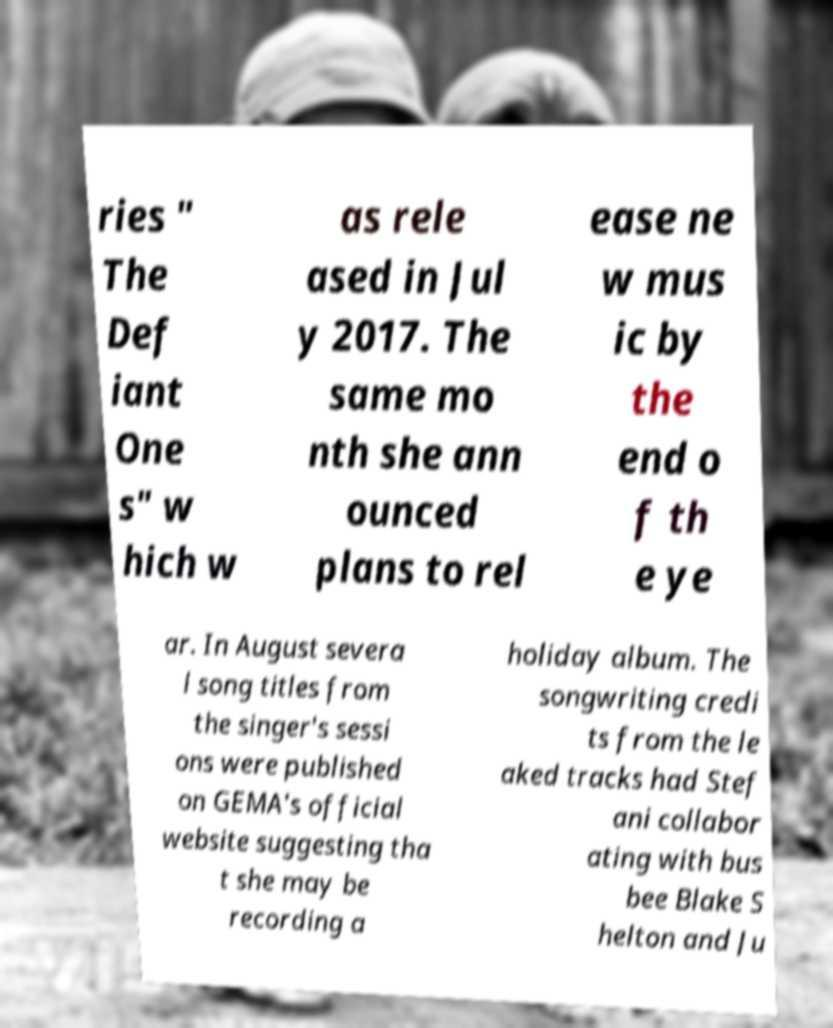Please read and relay the text visible in this image. What does it say? ries " The Def iant One s" w hich w as rele ased in Jul y 2017. The same mo nth she ann ounced plans to rel ease ne w mus ic by the end o f th e ye ar. In August severa l song titles from the singer's sessi ons were published on GEMA's official website suggesting tha t she may be recording a holiday album. The songwriting credi ts from the le aked tracks had Stef ani collabor ating with bus bee Blake S helton and Ju 